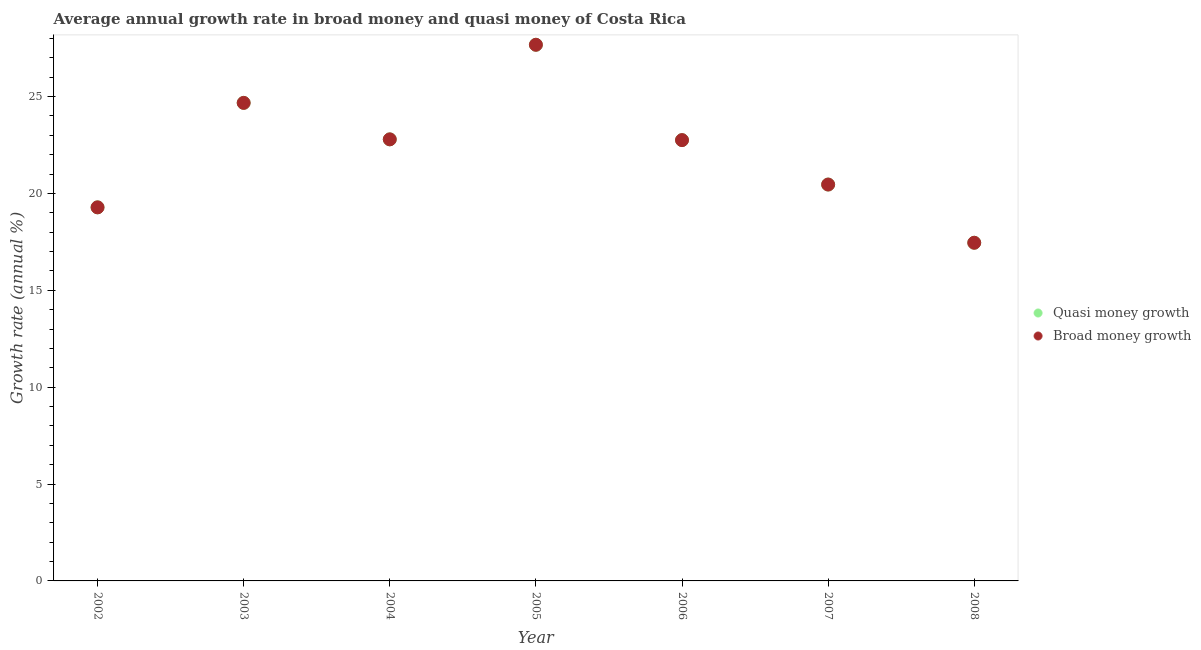Is the number of dotlines equal to the number of legend labels?
Your answer should be compact. Yes. What is the annual growth rate in broad money in 2006?
Keep it short and to the point. 22.76. Across all years, what is the maximum annual growth rate in quasi money?
Your answer should be compact. 27.68. Across all years, what is the minimum annual growth rate in broad money?
Your answer should be very brief. 17.46. What is the total annual growth rate in quasi money in the graph?
Your response must be concise. 155.1. What is the difference between the annual growth rate in quasi money in 2004 and that in 2007?
Ensure brevity in your answer.  2.33. What is the difference between the annual growth rate in broad money in 2002 and the annual growth rate in quasi money in 2005?
Your response must be concise. -8.39. What is the average annual growth rate in quasi money per year?
Offer a very short reply. 22.16. What is the ratio of the annual growth rate in broad money in 2004 to that in 2006?
Make the answer very short. 1. What is the difference between the highest and the second highest annual growth rate in broad money?
Your answer should be very brief. 3. What is the difference between the highest and the lowest annual growth rate in quasi money?
Provide a short and direct response. 10.22. In how many years, is the annual growth rate in broad money greater than the average annual growth rate in broad money taken over all years?
Give a very brief answer. 4. Is the annual growth rate in quasi money strictly greater than the annual growth rate in broad money over the years?
Offer a very short reply. No. Is the annual growth rate in broad money strictly less than the annual growth rate in quasi money over the years?
Your answer should be compact. No. How many dotlines are there?
Your answer should be very brief. 2. How many years are there in the graph?
Offer a terse response. 7. What is the difference between two consecutive major ticks on the Y-axis?
Offer a terse response. 5. Are the values on the major ticks of Y-axis written in scientific E-notation?
Your answer should be very brief. No. Does the graph contain any zero values?
Offer a very short reply. No. How many legend labels are there?
Provide a succinct answer. 2. What is the title of the graph?
Your response must be concise. Average annual growth rate in broad money and quasi money of Costa Rica. What is the label or title of the Y-axis?
Provide a short and direct response. Growth rate (annual %). What is the Growth rate (annual %) in Quasi money growth in 2002?
Your answer should be very brief. 19.28. What is the Growth rate (annual %) of Broad money growth in 2002?
Keep it short and to the point. 19.28. What is the Growth rate (annual %) in Quasi money growth in 2003?
Make the answer very short. 24.68. What is the Growth rate (annual %) of Broad money growth in 2003?
Provide a succinct answer. 24.68. What is the Growth rate (annual %) of Quasi money growth in 2004?
Provide a short and direct response. 22.79. What is the Growth rate (annual %) in Broad money growth in 2004?
Offer a terse response. 22.79. What is the Growth rate (annual %) in Quasi money growth in 2005?
Make the answer very short. 27.68. What is the Growth rate (annual %) in Broad money growth in 2005?
Give a very brief answer. 27.68. What is the Growth rate (annual %) in Quasi money growth in 2006?
Provide a short and direct response. 22.76. What is the Growth rate (annual %) in Broad money growth in 2006?
Provide a short and direct response. 22.76. What is the Growth rate (annual %) of Quasi money growth in 2007?
Give a very brief answer. 20.46. What is the Growth rate (annual %) of Broad money growth in 2007?
Your answer should be very brief. 20.46. What is the Growth rate (annual %) of Quasi money growth in 2008?
Make the answer very short. 17.46. What is the Growth rate (annual %) in Broad money growth in 2008?
Provide a succinct answer. 17.46. Across all years, what is the maximum Growth rate (annual %) in Quasi money growth?
Provide a short and direct response. 27.68. Across all years, what is the maximum Growth rate (annual %) in Broad money growth?
Ensure brevity in your answer.  27.68. Across all years, what is the minimum Growth rate (annual %) in Quasi money growth?
Give a very brief answer. 17.46. Across all years, what is the minimum Growth rate (annual %) of Broad money growth?
Provide a short and direct response. 17.46. What is the total Growth rate (annual %) in Quasi money growth in the graph?
Keep it short and to the point. 155.1. What is the total Growth rate (annual %) of Broad money growth in the graph?
Your response must be concise. 155.1. What is the difference between the Growth rate (annual %) in Quasi money growth in 2002 and that in 2003?
Offer a terse response. -5.39. What is the difference between the Growth rate (annual %) in Broad money growth in 2002 and that in 2003?
Provide a succinct answer. -5.39. What is the difference between the Growth rate (annual %) in Quasi money growth in 2002 and that in 2004?
Make the answer very short. -3.51. What is the difference between the Growth rate (annual %) in Broad money growth in 2002 and that in 2004?
Keep it short and to the point. -3.51. What is the difference between the Growth rate (annual %) in Quasi money growth in 2002 and that in 2005?
Offer a very short reply. -8.39. What is the difference between the Growth rate (annual %) of Broad money growth in 2002 and that in 2005?
Offer a terse response. -8.39. What is the difference between the Growth rate (annual %) in Quasi money growth in 2002 and that in 2006?
Provide a succinct answer. -3.47. What is the difference between the Growth rate (annual %) in Broad money growth in 2002 and that in 2006?
Your response must be concise. -3.47. What is the difference between the Growth rate (annual %) in Quasi money growth in 2002 and that in 2007?
Offer a terse response. -1.18. What is the difference between the Growth rate (annual %) of Broad money growth in 2002 and that in 2007?
Give a very brief answer. -1.18. What is the difference between the Growth rate (annual %) of Quasi money growth in 2002 and that in 2008?
Your answer should be very brief. 1.83. What is the difference between the Growth rate (annual %) in Broad money growth in 2002 and that in 2008?
Offer a very short reply. 1.83. What is the difference between the Growth rate (annual %) in Quasi money growth in 2003 and that in 2004?
Your answer should be very brief. 1.88. What is the difference between the Growth rate (annual %) in Broad money growth in 2003 and that in 2004?
Offer a very short reply. 1.88. What is the difference between the Growth rate (annual %) of Quasi money growth in 2003 and that in 2005?
Your answer should be compact. -3. What is the difference between the Growth rate (annual %) in Broad money growth in 2003 and that in 2005?
Give a very brief answer. -3. What is the difference between the Growth rate (annual %) in Quasi money growth in 2003 and that in 2006?
Provide a short and direct response. 1.92. What is the difference between the Growth rate (annual %) of Broad money growth in 2003 and that in 2006?
Provide a succinct answer. 1.92. What is the difference between the Growth rate (annual %) of Quasi money growth in 2003 and that in 2007?
Give a very brief answer. 4.22. What is the difference between the Growth rate (annual %) of Broad money growth in 2003 and that in 2007?
Ensure brevity in your answer.  4.22. What is the difference between the Growth rate (annual %) of Quasi money growth in 2003 and that in 2008?
Make the answer very short. 7.22. What is the difference between the Growth rate (annual %) in Broad money growth in 2003 and that in 2008?
Offer a very short reply. 7.22. What is the difference between the Growth rate (annual %) in Quasi money growth in 2004 and that in 2005?
Give a very brief answer. -4.88. What is the difference between the Growth rate (annual %) in Broad money growth in 2004 and that in 2005?
Your answer should be compact. -4.88. What is the difference between the Growth rate (annual %) of Quasi money growth in 2004 and that in 2006?
Keep it short and to the point. 0.04. What is the difference between the Growth rate (annual %) in Broad money growth in 2004 and that in 2006?
Provide a short and direct response. 0.04. What is the difference between the Growth rate (annual %) of Quasi money growth in 2004 and that in 2007?
Give a very brief answer. 2.33. What is the difference between the Growth rate (annual %) in Broad money growth in 2004 and that in 2007?
Give a very brief answer. 2.33. What is the difference between the Growth rate (annual %) in Quasi money growth in 2004 and that in 2008?
Your answer should be compact. 5.34. What is the difference between the Growth rate (annual %) of Broad money growth in 2004 and that in 2008?
Your answer should be very brief. 5.34. What is the difference between the Growth rate (annual %) in Quasi money growth in 2005 and that in 2006?
Provide a short and direct response. 4.92. What is the difference between the Growth rate (annual %) in Broad money growth in 2005 and that in 2006?
Your response must be concise. 4.92. What is the difference between the Growth rate (annual %) in Quasi money growth in 2005 and that in 2007?
Make the answer very short. 7.21. What is the difference between the Growth rate (annual %) of Broad money growth in 2005 and that in 2007?
Provide a succinct answer. 7.21. What is the difference between the Growth rate (annual %) of Quasi money growth in 2005 and that in 2008?
Ensure brevity in your answer.  10.22. What is the difference between the Growth rate (annual %) in Broad money growth in 2005 and that in 2008?
Ensure brevity in your answer.  10.22. What is the difference between the Growth rate (annual %) of Quasi money growth in 2006 and that in 2007?
Provide a succinct answer. 2.29. What is the difference between the Growth rate (annual %) in Broad money growth in 2006 and that in 2007?
Ensure brevity in your answer.  2.29. What is the difference between the Growth rate (annual %) in Quasi money growth in 2006 and that in 2008?
Keep it short and to the point. 5.3. What is the difference between the Growth rate (annual %) of Broad money growth in 2006 and that in 2008?
Offer a very short reply. 5.3. What is the difference between the Growth rate (annual %) in Quasi money growth in 2007 and that in 2008?
Make the answer very short. 3.01. What is the difference between the Growth rate (annual %) of Broad money growth in 2007 and that in 2008?
Make the answer very short. 3.01. What is the difference between the Growth rate (annual %) of Quasi money growth in 2002 and the Growth rate (annual %) of Broad money growth in 2003?
Ensure brevity in your answer.  -5.39. What is the difference between the Growth rate (annual %) of Quasi money growth in 2002 and the Growth rate (annual %) of Broad money growth in 2004?
Offer a terse response. -3.51. What is the difference between the Growth rate (annual %) in Quasi money growth in 2002 and the Growth rate (annual %) in Broad money growth in 2005?
Provide a succinct answer. -8.39. What is the difference between the Growth rate (annual %) in Quasi money growth in 2002 and the Growth rate (annual %) in Broad money growth in 2006?
Make the answer very short. -3.47. What is the difference between the Growth rate (annual %) of Quasi money growth in 2002 and the Growth rate (annual %) of Broad money growth in 2007?
Offer a very short reply. -1.18. What is the difference between the Growth rate (annual %) of Quasi money growth in 2002 and the Growth rate (annual %) of Broad money growth in 2008?
Give a very brief answer. 1.83. What is the difference between the Growth rate (annual %) in Quasi money growth in 2003 and the Growth rate (annual %) in Broad money growth in 2004?
Provide a short and direct response. 1.88. What is the difference between the Growth rate (annual %) of Quasi money growth in 2003 and the Growth rate (annual %) of Broad money growth in 2005?
Offer a terse response. -3. What is the difference between the Growth rate (annual %) of Quasi money growth in 2003 and the Growth rate (annual %) of Broad money growth in 2006?
Provide a succinct answer. 1.92. What is the difference between the Growth rate (annual %) of Quasi money growth in 2003 and the Growth rate (annual %) of Broad money growth in 2007?
Make the answer very short. 4.22. What is the difference between the Growth rate (annual %) of Quasi money growth in 2003 and the Growth rate (annual %) of Broad money growth in 2008?
Ensure brevity in your answer.  7.22. What is the difference between the Growth rate (annual %) of Quasi money growth in 2004 and the Growth rate (annual %) of Broad money growth in 2005?
Your response must be concise. -4.88. What is the difference between the Growth rate (annual %) of Quasi money growth in 2004 and the Growth rate (annual %) of Broad money growth in 2006?
Offer a very short reply. 0.04. What is the difference between the Growth rate (annual %) of Quasi money growth in 2004 and the Growth rate (annual %) of Broad money growth in 2007?
Give a very brief answer. 2.33. What is the difference between the Growth rate (annual %) of Quasi money growth in 2004 and the Growth rate (annual %) of Broad money growth in 2008?
Your answer should be compact. 5.34. What is the difference between the Growth rate (annual %) in Quasi money growth in 2005 and the Growth rate (annual %) in Broad money growth in 2006?
Your response must be concise. 4.92. What is the difference between the Growth rate (annual %) in Quasi money growth in 2005 and the Growth rate (annual %) in Broad money growth in 2007?
Provide a succinct answer. 7.21. What is the difference between the Growth rate (annual %) in Quasi money growth in 2005 and the Growth rate (annual %) in Broad money growth in 2008?
Offer a very short reply. 10.22. What is the difference between the Growth rate (annual %) in Quasi money growth in 2006 and the Growth rate (annual %) in Broad money growth in 2007?
Ensure brevity in your answer.  2.29. What is the difference between the Growth rate (annual %) in Quasi money growth in 2006 and the Growth rate (annual %) in Broad money growth in 2008?
Offer a very short reply. 5.3. What is the difference between the Growth rate (annual %) of Quasi money growth in 2007 and the Growth rate (annual %) of Broad money growth in 2008?
Offer a terse response. 3.01. What is the average Growth rate (annual %) in Quasi money growth per year?
Your response must be concise. 22.16. What is the average Growth rate (annual %) of Broad money growth per year?
Keep it short and to the point. 22.16. In the year 2002, what is the difference between the Growth rate (annual %) of Quasi money growth and Growth rate (annual %) of Broad money growth?
Ensure brevity in your answer.  0. In the year 2006, what is the difference between the Growth rate (annual %) in Quasi money growth and Growth rate (annual %) in Broad money growth?
Your answer should be very brief. 0. In the year 2008, what is the difference between the Growth rate (annual %) in Quasi money growth and Growth rate (annual %) in Broad money growth?
Provide a short and direct response. 0. What is the ratio of the Growth rate (annual %) in Quasi money growth in 2002 to that in 2003?
Your answer should be compact. 0.78. What is the ratio of the Growth rate (annual %) in Broad money growth in 2002 to that in 2003?
Offer a terse response. 0.78. What is the ratio of the Growth rate (annual %) in Quasi money growth in 2002 to that in 2004?
Your answer should be very brief. 0.85. What is the ratio of the Growth rate (annual %) of Broad money growth in 2002 to that in 2004?
Your response must be concise. 0.85. What is the ratio of the Growth rate (annual %) of Quasi money growth in 2002 to that in 2005?
Provide a succinct answer. 0.7. What is the ratio of the Growth rate (annual %) of Broad money growth in 2002 to that in 2005?
Offer a very short reply. 0.7. What is the ratio of the Growth rate (annual %) of Quasi money growth in 2002 to that in 2006?
Your answer should be compact. 0.85. What is the ratio of the Growth rate (annual %) of Broad money growth in 2002 to that in 2006?
Offer a terse response. 0.85. What is the ratio of the Growth rate (annual %) of Quasi money growth in 2002 to that in 2007?
Keep it short and to the point. 0.94. What is the ratio of the Growth rate (annual %) of Broad money growth in 2002 to that in 2007?
Ensure brevity in your answer.  0.94. What is the ratio of the Growth rate (annual %) in Quasi money growth in 2002 to that in 2008?
Your response must be concise. 1.1. What is the ratio of the Growth rate (annual %) of Broad money growth in 2002 to that in 2008?
Make the answer very short. 1.1. What is the ratio of the Growth rate (annual %) of Quasi money growth in 2003 to that in 2004?
Your response must be concise. 1.08. What is the ratio of the Growth rate (annual %) in Broad money growth in 2003 to that in 2004?
Your answer should be very brief. 1.08. What is the ratio of the Growth rate (annual %) in Quasi money growth in 2003 to that in 2005?
Make the answer very short. 0.89. What is the ratio of the Growth rate (annual %) of Broad money growth in 2003 to that in 2005?
Your answer should be very brief. 0.89. What is the ratio of the Growth rate (annual %) of Quasi money growth in 2003 to that in 2006?
Give a very brief answer. 1.08. What is the ratio of the Growth rate (annual %) of Broad money growth in 2003 to that in 2006?
Offer a terse response. 1.08. What is the ratio of the Growth rate (annual %) in Quasi money growth in 2003 to that in 2007?
Offer a terse response. 1.21. What is the ratio of the Growth rate (annual %) of Broad money growth in 2003 to that in 2007?
Your response must be concise. 1.21. What is the ratio of the Growth rate (annual %) in Quasi money growth in 2003 to that in 2008?
Make the answer very short. 1.41. What is the ratio of the Growth rate (annual %) of Broad money growth in 2003 to that in 2008?
Ensure brevity in your answer.  1.41. What is the ratio of the Growth rate (annual %) in Quasi money growth in 2004 to that in 2005?
Give a very brief answer. 0.82. What is the ratio of the Growth rate (annual %) of Broad money growth in 2004 to that in 2005?
Keep it short and to the point. 0.82. What is the ratio of the Growth rate (annual %) of Quasi money growth in 2004 to that in 2007?
Keep it short and to the point. 1.11. What is the ratio of the Growth rate (annual %) in Broad money growth in 2004 to that in 2007?
Your response must be concise. 1.11. What is the ratio of the Growth rate (annual %) in Quasi money growth in 2004 to that in 2008?
Your response must be concise. 1.31. What is the ratio of the Growth rate (annual %) of Broad money growth in 2004 to that in 2008?
Make the answer very short. 1.31. What is the ratio of the Growth rate (annual %) of Quasi money growth in 2005 to that in 2006?
Make the answer very short. 1.22. What is the ratio of the Growth rate (annual %) of Broad money growth in 2005 to that in 2006?
Provide a short and direct response. 1.22. What is the ratio of the Growth rate (annual %) of Quasi money growth in 2005 to that in 2007?
Provide a short and direct response. 1.35. What is the ratio of the Growth rate (annual %) in Broad money growth in 2005 to that in 2007?
Offer a terse response. 1.35. What is the ratio of the Growth rate (annual %) of Quasi money growth in 2005 to that in 2008?
Your answer should be very brief. 1.59. What is the ratio of the Growth rate (annual %) in Broad money growth in 2005 to that in 2008?
Provide a short and direct response. 1.59. What is the ratio of the Growth rate (annual %) in Quasi money growth in 2006 to that in 2007?
Your answer should be compact. 1.11. What is the ratio of the Growth rate (annual %) of Broad money growth in 2006 to that in 2007?
Offer a very short reply. 1.11. What is the ratio of the Growth rate (annual %) in Quasi money growth in 2006 to that in 2008?
Give a very brief answer. 1.3. What is the ratio of the Growth rate (annual %) in Broad money growth in 2006 to that in 2008?
Offer a terse response. 1.3. What is the ratio of the Growth rate (annual %) of Quasi money growth in 2007 to that in 2008?
Offer a very short reply. 1.17. What is the ratio of the Growth rate (annual %) in Broad money growth in 2007 to that in 2008?
Provide a succinct answer. 1.17. What is the difference between the highest and the second highest Growth rate (annual %) of Quasi money growth?
Offer a terse response. 3. What is the difference between the highest and the second highest Growth rate (annual %) in Broad money growth?
Ensure brevity in your answer.  3. What is the difference between the highest and the lowest Growth rate (annual %) of Quasi money growth?
Offer a terse response. 10.22. What is the difference between the highest and the lowest Growth rate (annual %) of Broad money growth?
Provide a short and direct response. 10.22. 